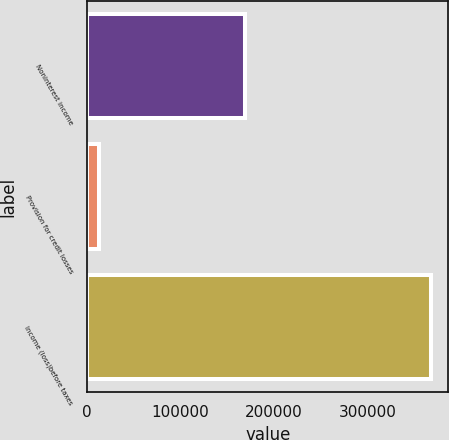Convert chart to OTSL. <chart><loc_0><loc_0><loc_500><loc_500><bar_chart><fcel>Noninterest income<fcel>Provision for credit losses<fcel>Income (loss)before taxes<nl><fcel>169157<fcel>12190<fcel>368424<nl></chart> 